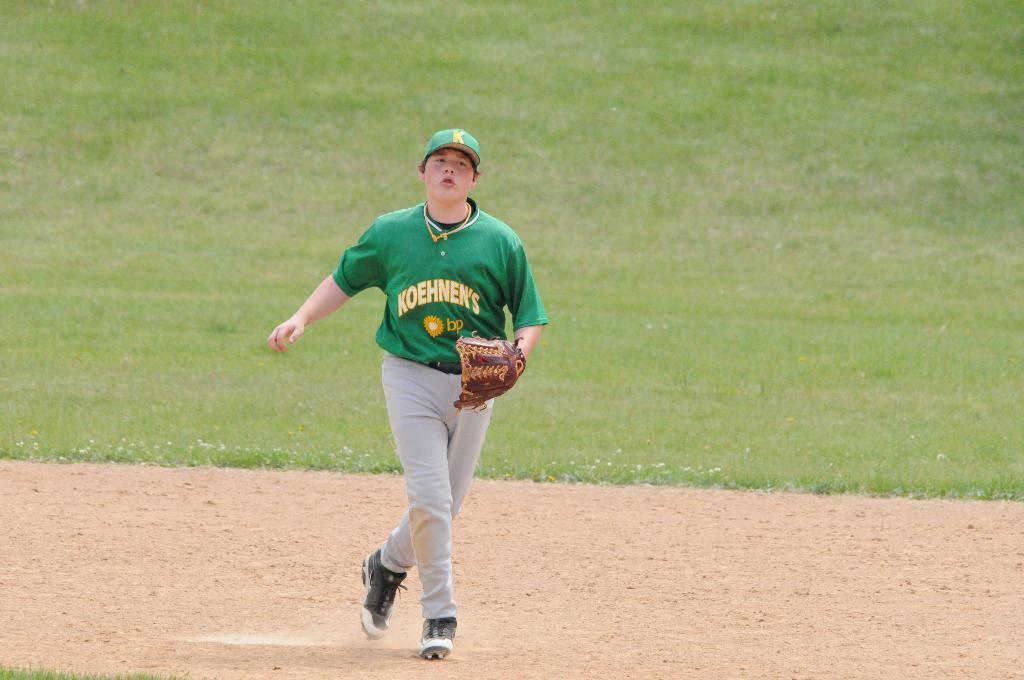<image>
Render a clear and concise summary of the photo. A teenager wearing a green top bearing the names Koehnen's and BP runs on the baseball field. 